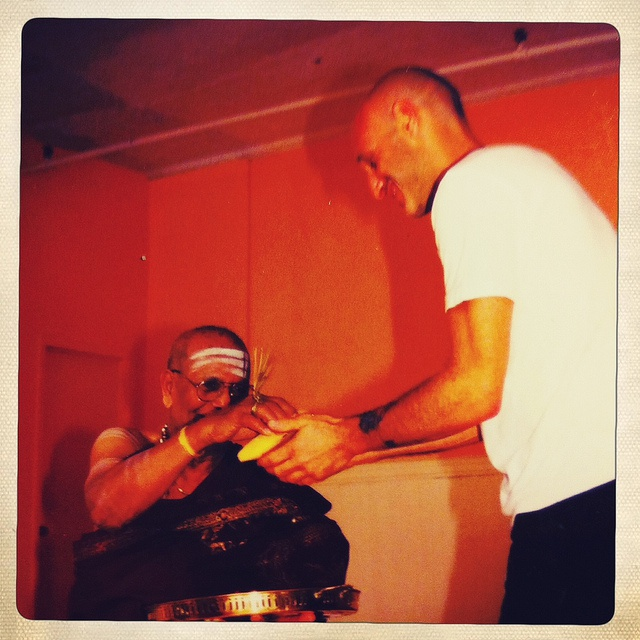Describe the objects in this image and their specific colors. I can see people in beige, black, red, and orange tones, people in beige, brown, red, and maroon tones, and banana in beige, gold, orange, brown, and red tones in this image. 